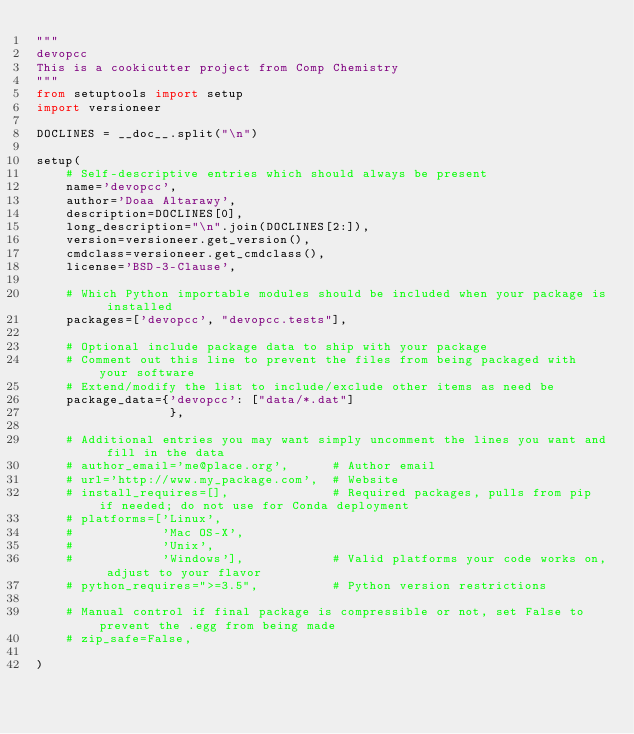<code> <loc_0><loc_0><loc_500><loc_500><_Python_>"""
devopcc
This is a cookicutter project from Comp Chemistry
"""
from setuptools import setup
import versioneer

DOCLINES = __doc__.split("\n")

setup(
    # Self-descriptive entries which should always be present
    name='devopcc',
    author='Doaa Altarawy',
    description=DOCLINES[0],
    long_description="\n".join(DOCLINES[2:]),
    version=versioneer.get_version(),
    cmdclass=versioneer.get_cmdclass(),
    license='BSD-3-Clause',

    # Which Python importable modules should be included when your package is installed
    packages=['devopcc', "devopcc.tests"],

    # Optional include package data to ship with your package
    # Comment out this line to prevent the files from being packaged with your software
    # Extend/modify the list to include/exclude other items as need be
    package_data={'devopcc': ["data/*.dat"]
                  },

    # Additional entries you may want simply uncomment the lines you want and fill in the data
    # author_email='me@place.org',      # Author email
    # url='http://www.my_package.com',  # Website
    # install_requires=[],              # Required packages, pulls from pip if needed; do not use for Conda deployment
    # platforms=['Linux',
    #            'Mac OS-X',
    #            'Unix',
    #            'Windows'],            # Valid platforms your code works on, adjust to your flavor
    # python_requires=">=3.5",          # Python version restrictions

    # Manual control if final package is compressible or not, set False to prevent the .egg from being made
    # zip_safe=False,

)
</code> 